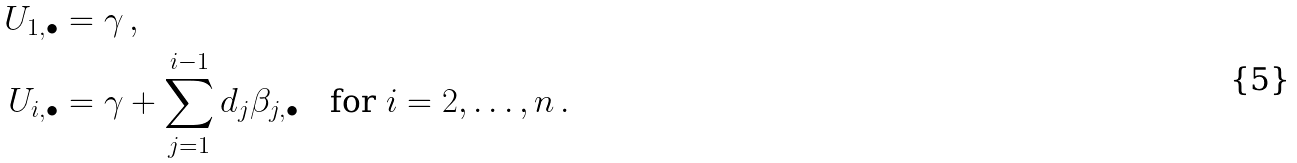<formula> <loc_0><loc_0><loc_500><loc_500>U _ { 1 , \bullet } & = \gamma \, , \\ U _ { i , \bullet } & = \gamma + \sum _ { j = 1 } ^ { i - 1 } d _ { j } \beta _ { j , \bullet } \quad \text {for } i = 2 , \dots , n \, .</formula> 